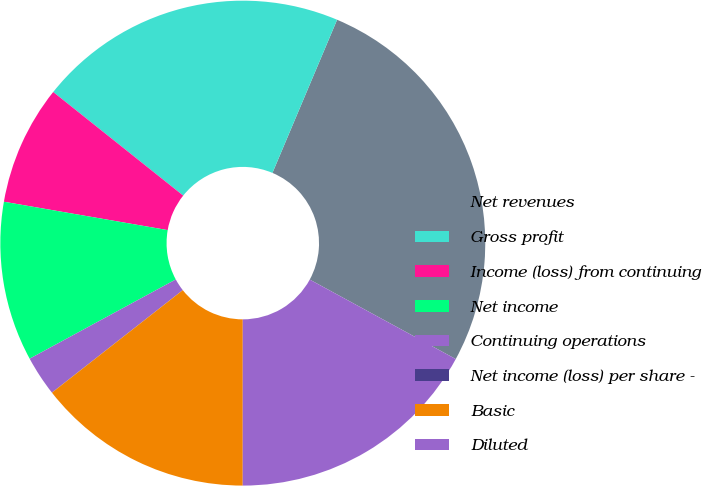<chart> <loc_0><loc_0><loc_500><loc_500><pie_chart><fcel>Net revenues<fcel>Gross profit<fcel>Income (loss) from continuing<fcel>Net income<fcel>Continuing operations<fcel>Net income (loss) per share -<fcel>Basic<fcel>Diluted<nl><fcel>26.58%<fcel>20.65%<fcel>7.98%<fcel>10.64%<fcel>2.66%<fcel>0.01%<fcel>14.42%<fcel>17.07%<nl></chart> 